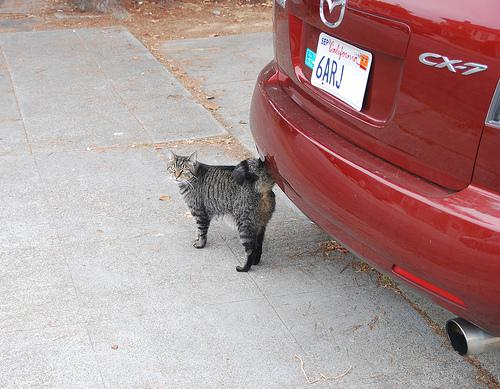Question: where was this photo taken?
Choices:
A. The treehouse.
B. The police sTation.
C. On the sidewalk.
D. The back seat.
Answer with the letter. Answer: C Question: what state is the car from?
Choices:
A. Oklahoma.
B. California.
C. Texas.
D. Iowa.
Answer with the letter. Answer: B Question: why is the license plate half-covered?
Choices:
A. Privacy.
B. It's dirty.
C. There is mud on it.
D. The trailer is blocking it.
Answer with the letter. Answer: A Question: what animal is behind the car?
Choices:
A. Cat.
B. Dog.
C. Goat.
D. Horse.
Answer with the letter. Answer: A 